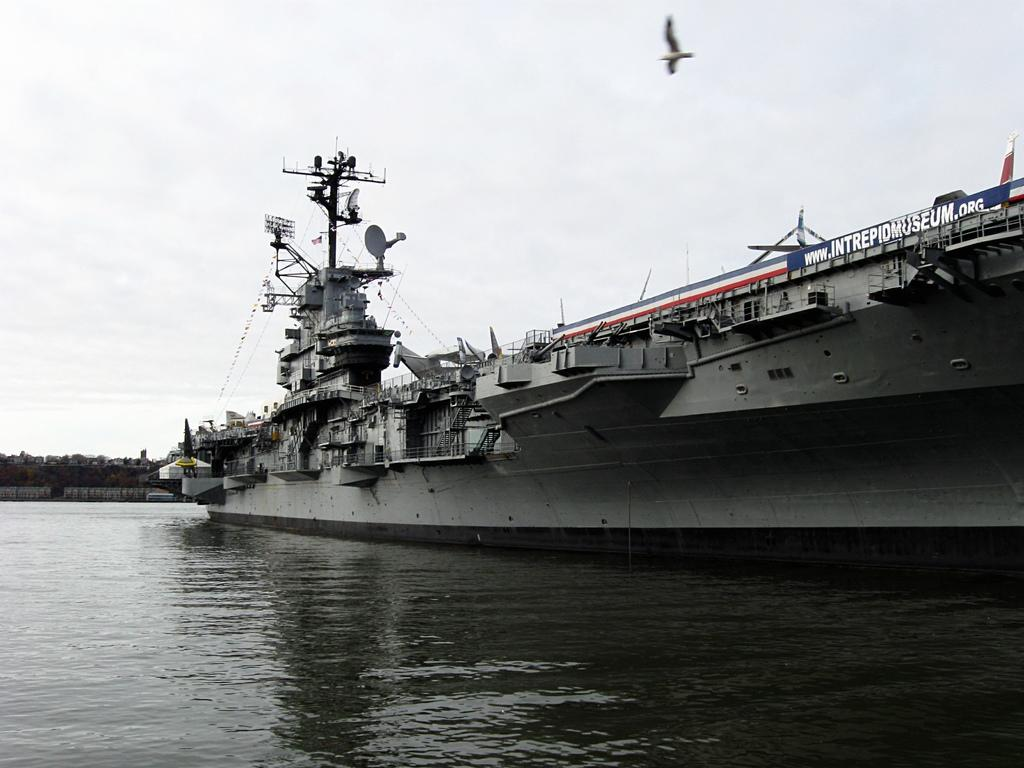What is the main subject in the image? There is a ship in the image. What is the ship floating on? There is water in the image. What else can be seen in the sky besides the water? A bird is flying in the image. What color is the sky in the image? The sky is white in color. What grade does the judge give to the river in the image? There is no river present in the image, and therefore no grade can be given. 